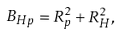<formula> <loc_0><loc_0><loc_500><loc_500>B _ { H p } = R _ { p } ^ { 2 } + R _ { H } ^ { 2 } ,</formula> 